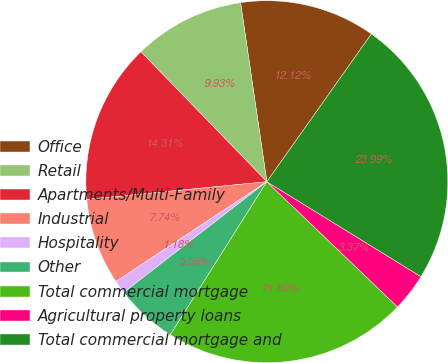Convert chart. <chart><loc_0><loc_0><loc_500><loc_500><pie_chart><fcel>Office<fcel>Retail<fcel>Apartments/Multi-Family<fcel>Industrial<fcel>Hospitality<fcel>Other<fcel>Total commercial mortgage<fcel>Agricultural property loans<fcel>Total commercial mortgage and<nl><fcel>12.12%<fcel>9.93%<fcel>14.31%<fcel>7.74%<fcel>1.18%<fcel>5.56%<fcel>21.8%<fcel>3.37%<fcel>23.99%<nl></chart> 